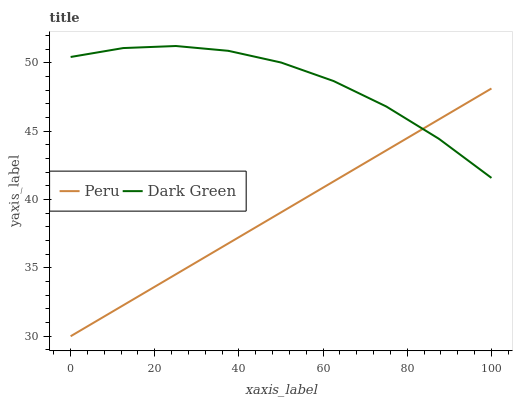Does Peru have the minimum area under the curve?
Answer yes or no. Yes. Does Dark Green have the maximum area under the curve?
Answer yes or no. Yes. Does Dark Green have the minimum area under the curve?
Answer yes or no. No. Is Peru the smoothest?
Answer yes or no. Yes. Is Dark Green the roughest?
Answer yes or no. Yes. Is Dark Green the smoothest?
Answer yes or no. No. Does Peru have the lowest value?
Answer yes or no. Yes. Does Dark Green have the lowest value?
Answer yes or no. No. Does Dark Green have the highest value?
Answer yes or no. Yes. Does Peru intersect Dark Green?
Answer yes or no. Yes. Is Peru less than Dark Green?
Answer yes or no. No. Is Peru greater than Dark Green?
Answer yes or no. No. 